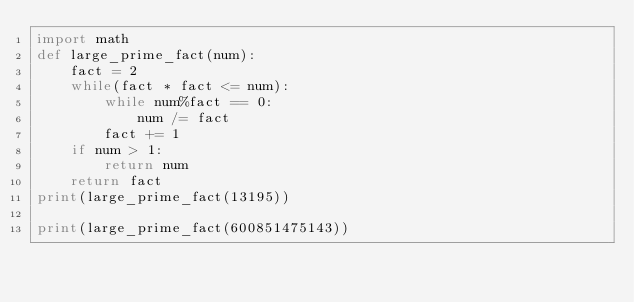<code> <loc_0><loc_0><loc_500><loc_500><_Python_>import math
def large_prime_fact(num):
    fact = 2
    while(fact * fact <= num):
        while num%fact == 0:
            num /= fact
        fact += 1
    if num > 1:
        return num
    return fact
print(large_prime_fact(13195))  

print(large_prime_fact(600851475143))</code> 